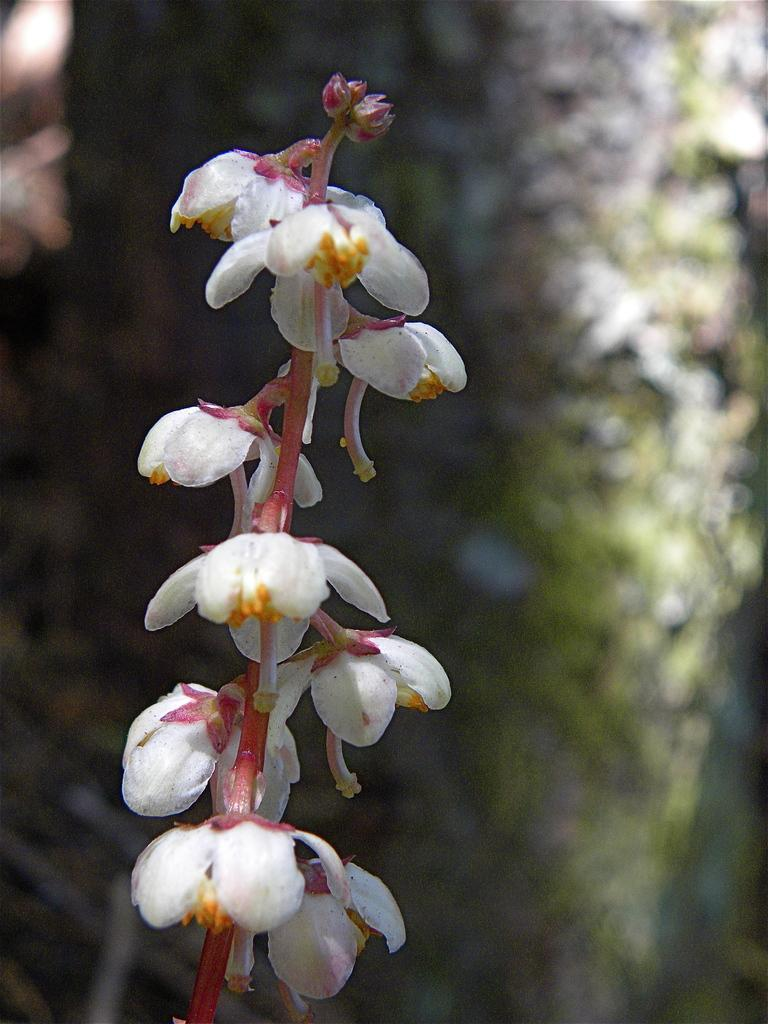What type of flowers can be seen in the image? There are white color flowers in the image. What is the flowers attached to? The flowers belong to a plant. How would you describe the background of the image? The background of the image is blurred. What color is the background? The background color is green. What direction are the boats traveling in the image? There are no boats present in the image. 